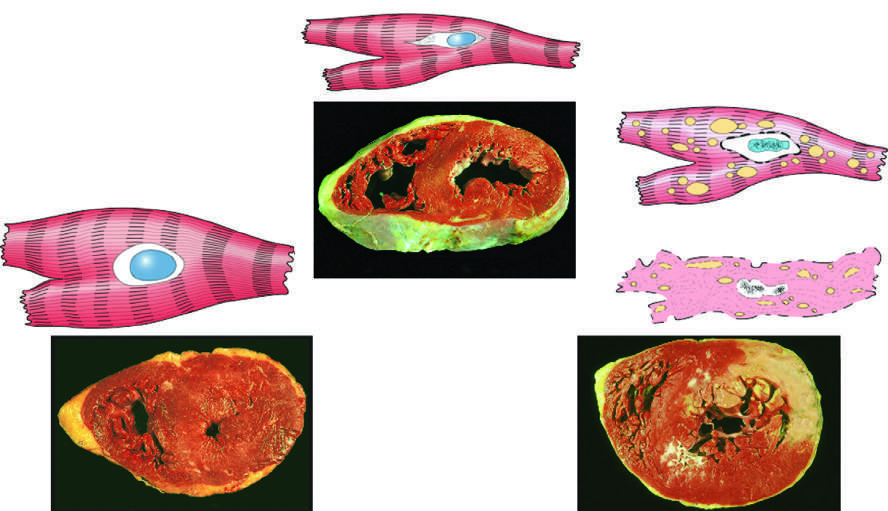when is failure to stain due to enzyme loss?
Answer the question using a single word or phrase. After cell death 